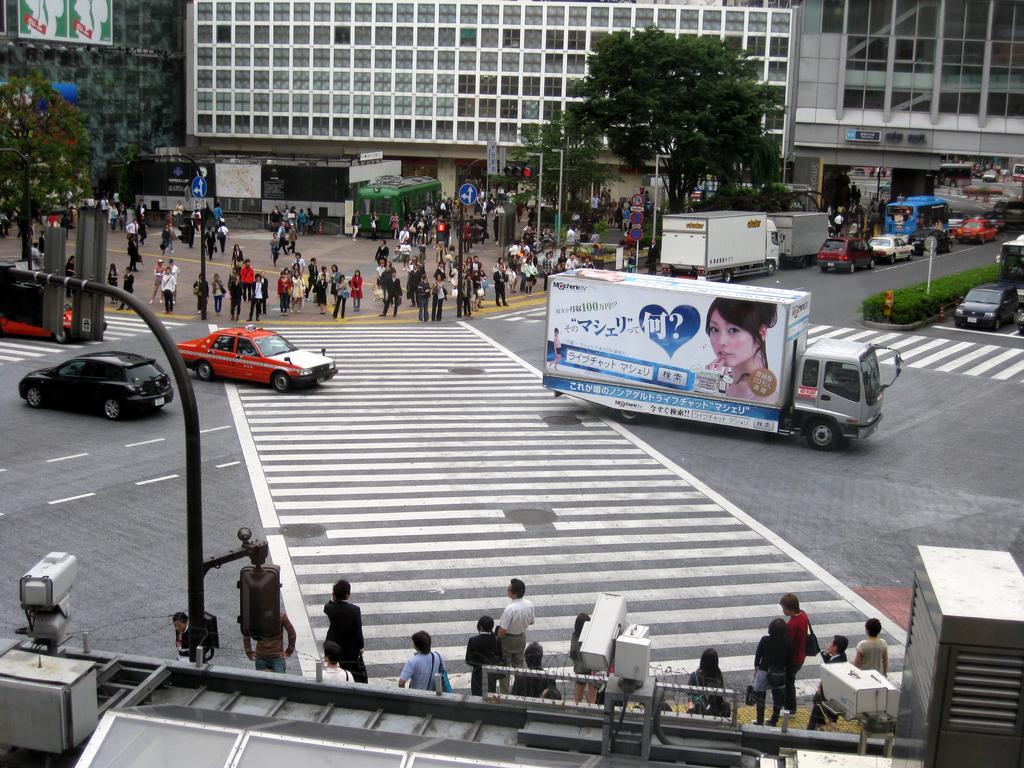Please provide a concise description of this image. In this image there are vehicles on the road. There are people standing. There are signal boards, light poles, trees, buildings, bushes, cameras and bill boards. 